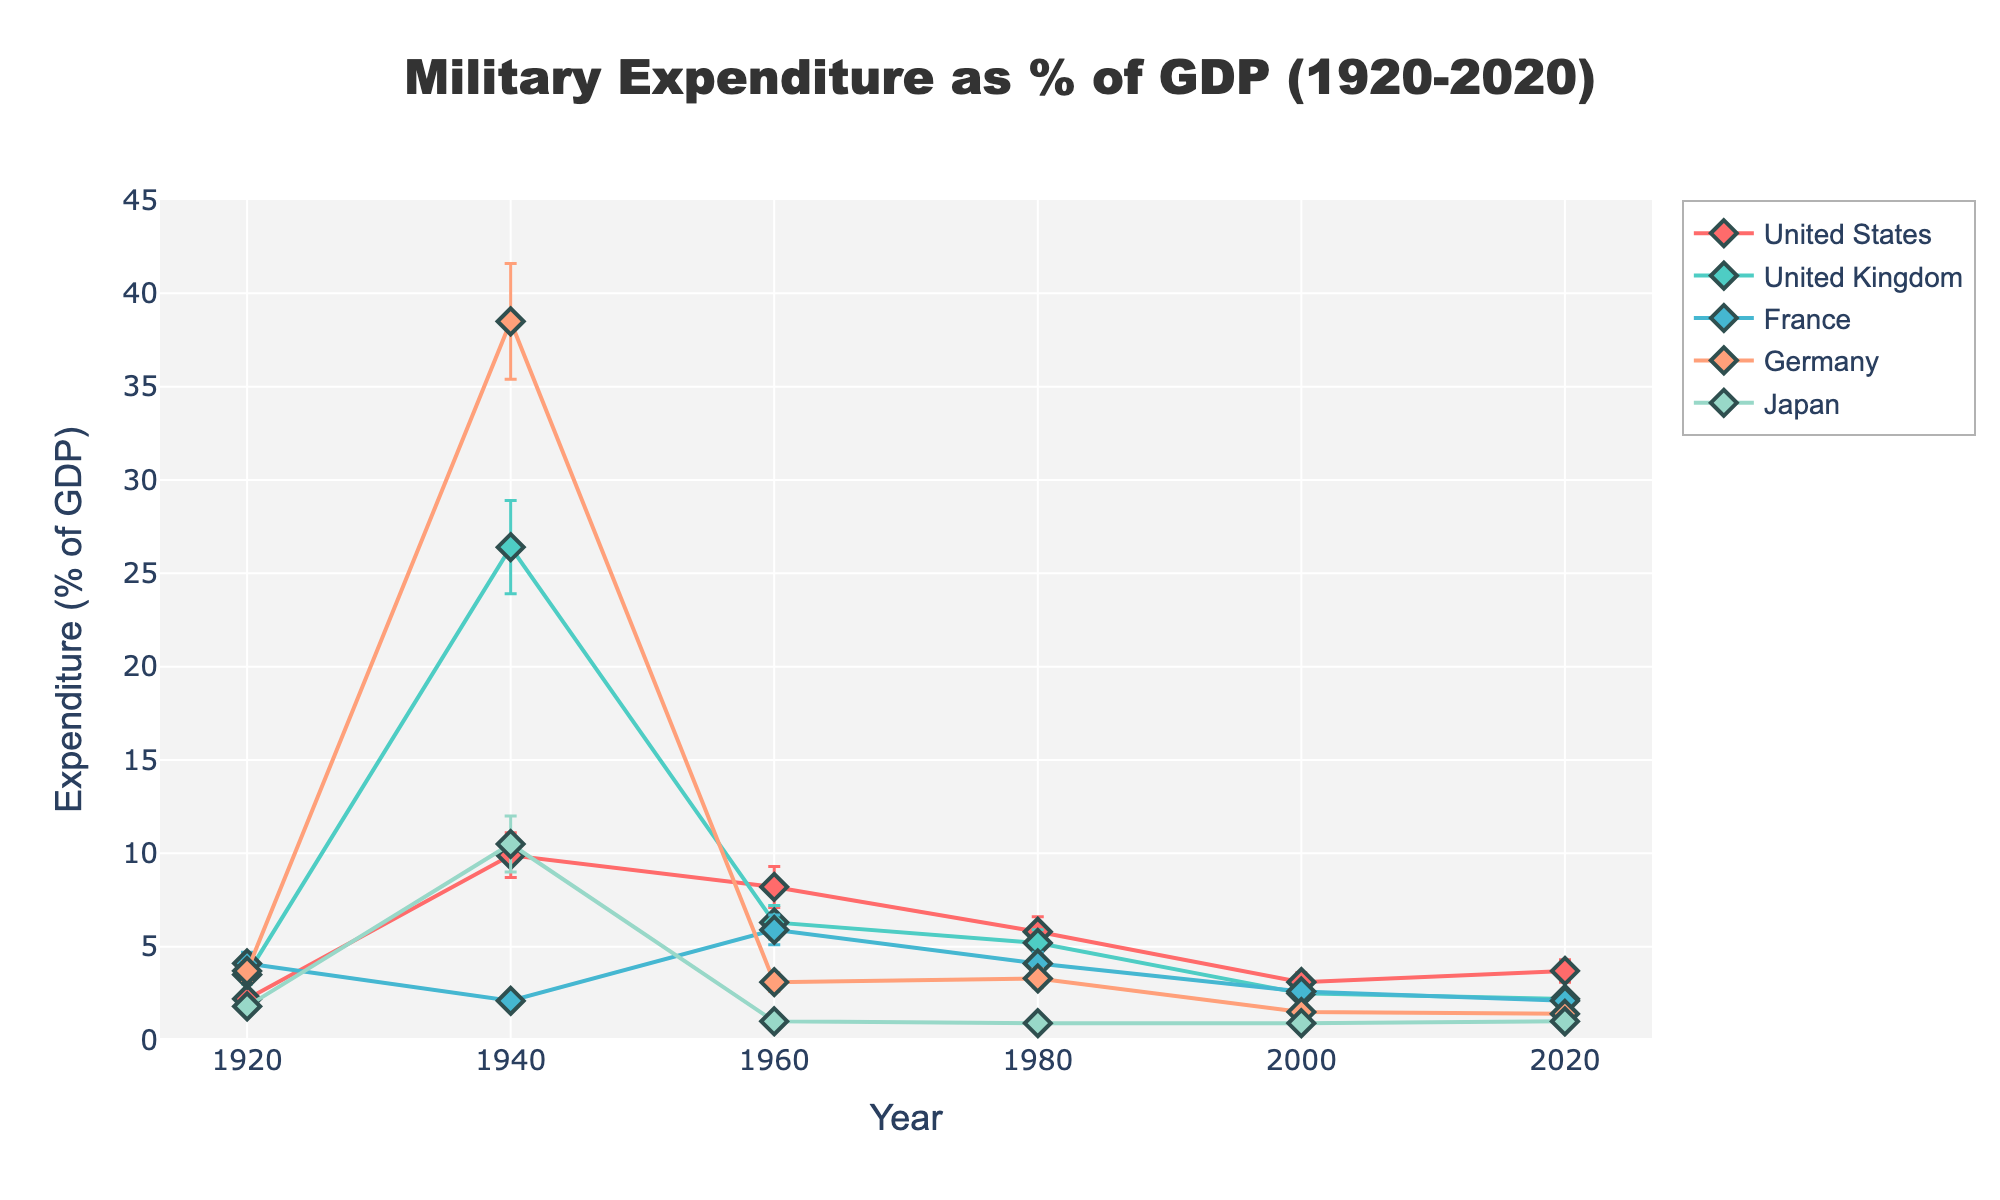What is the title of the plot? The title is positioned at the top middle of the plot and reads "Military Expenditure as % of GDP (1920-2020)". This title summarizes the context and time span of the data.
Answer: Military Expenditure as % of GDP (1920-2020) Which country had the highest military expenditure as a percentage of GDP in 1940? To determine this, examine the data points for 1940 and find the highest y-value among the countries. For 1940, Germany has the highest value at 38.5%.
Answer: Germany What is the general trend of military expenditure for the United States from 1920 to 2020? Observing the data points for the United States from 1920 to 2020 shows a peak during WWII (1940) and a gradual decrease thereafter, with small fluctuations. The values start at 2.2% in 1920, peak at 9.9% in 1940, and decline to 3.7% by 2020.
Answer: Fluctuating with a peak in 1940, then generally decreasing How did the military expenditure of Japan change from 1940 to 1960? Check the data points for Japan in 1940 and 1960. In 1940, Japan's expenditure was 10.5%, and it dropped significantly to 1.0% by 1960.
Answer: Decreased significantly Which country had the lowest military expenditure as a percentage of GDP in 2020? By reviewing the data points for 2020, the country with the lowest value is identified. Japan had the lowest military expenditure at 1.0%.
Answer: Japan Compare the military expenditures of France and Germany in 1920. Which country had a higher expenditure, and by how much? Look at the 1920 data points for France and Germany. France had 4.1%, while Germany had 3.7%. The difference is 4.1% - 3.7% = 0.4%.
Answer: France, by 0.4% Between which two decades did the United Kingdom experience the largest drop in military expenditure as a percentage of GDP? Examine the data points for the United Kingdom across the decades and calculate the differences: 26.4% (1940) to 6.3% (1960) shows the largest drop of 20.1 percentage points.
Answer: 1940 to 1960 What's the standard deviation of Germany's military expenditure in 1980? The plot includes error bars that represent the standard deviation. For Germany in 1980, the standard deviation is specified as 0.5%.
Answer: 0.5% Which country had the most stable military expenditure as a percentage of GDP from 1920 to 2020? Examining the data and looking for the smallest changes over the years, Japan shows the least fluctuation, staying around 1.0% to 1.8%.
Answer: Japan 